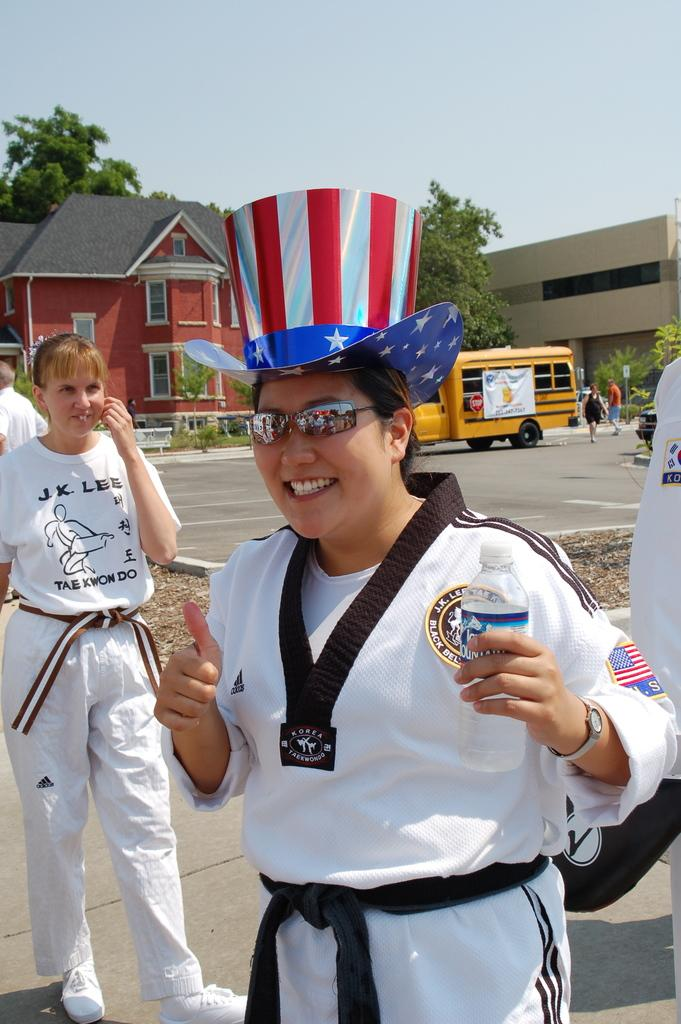<image>
Describe the image concisely. A woman is standing on a sidewalk wearing a t-shirt with the letter j on it. 